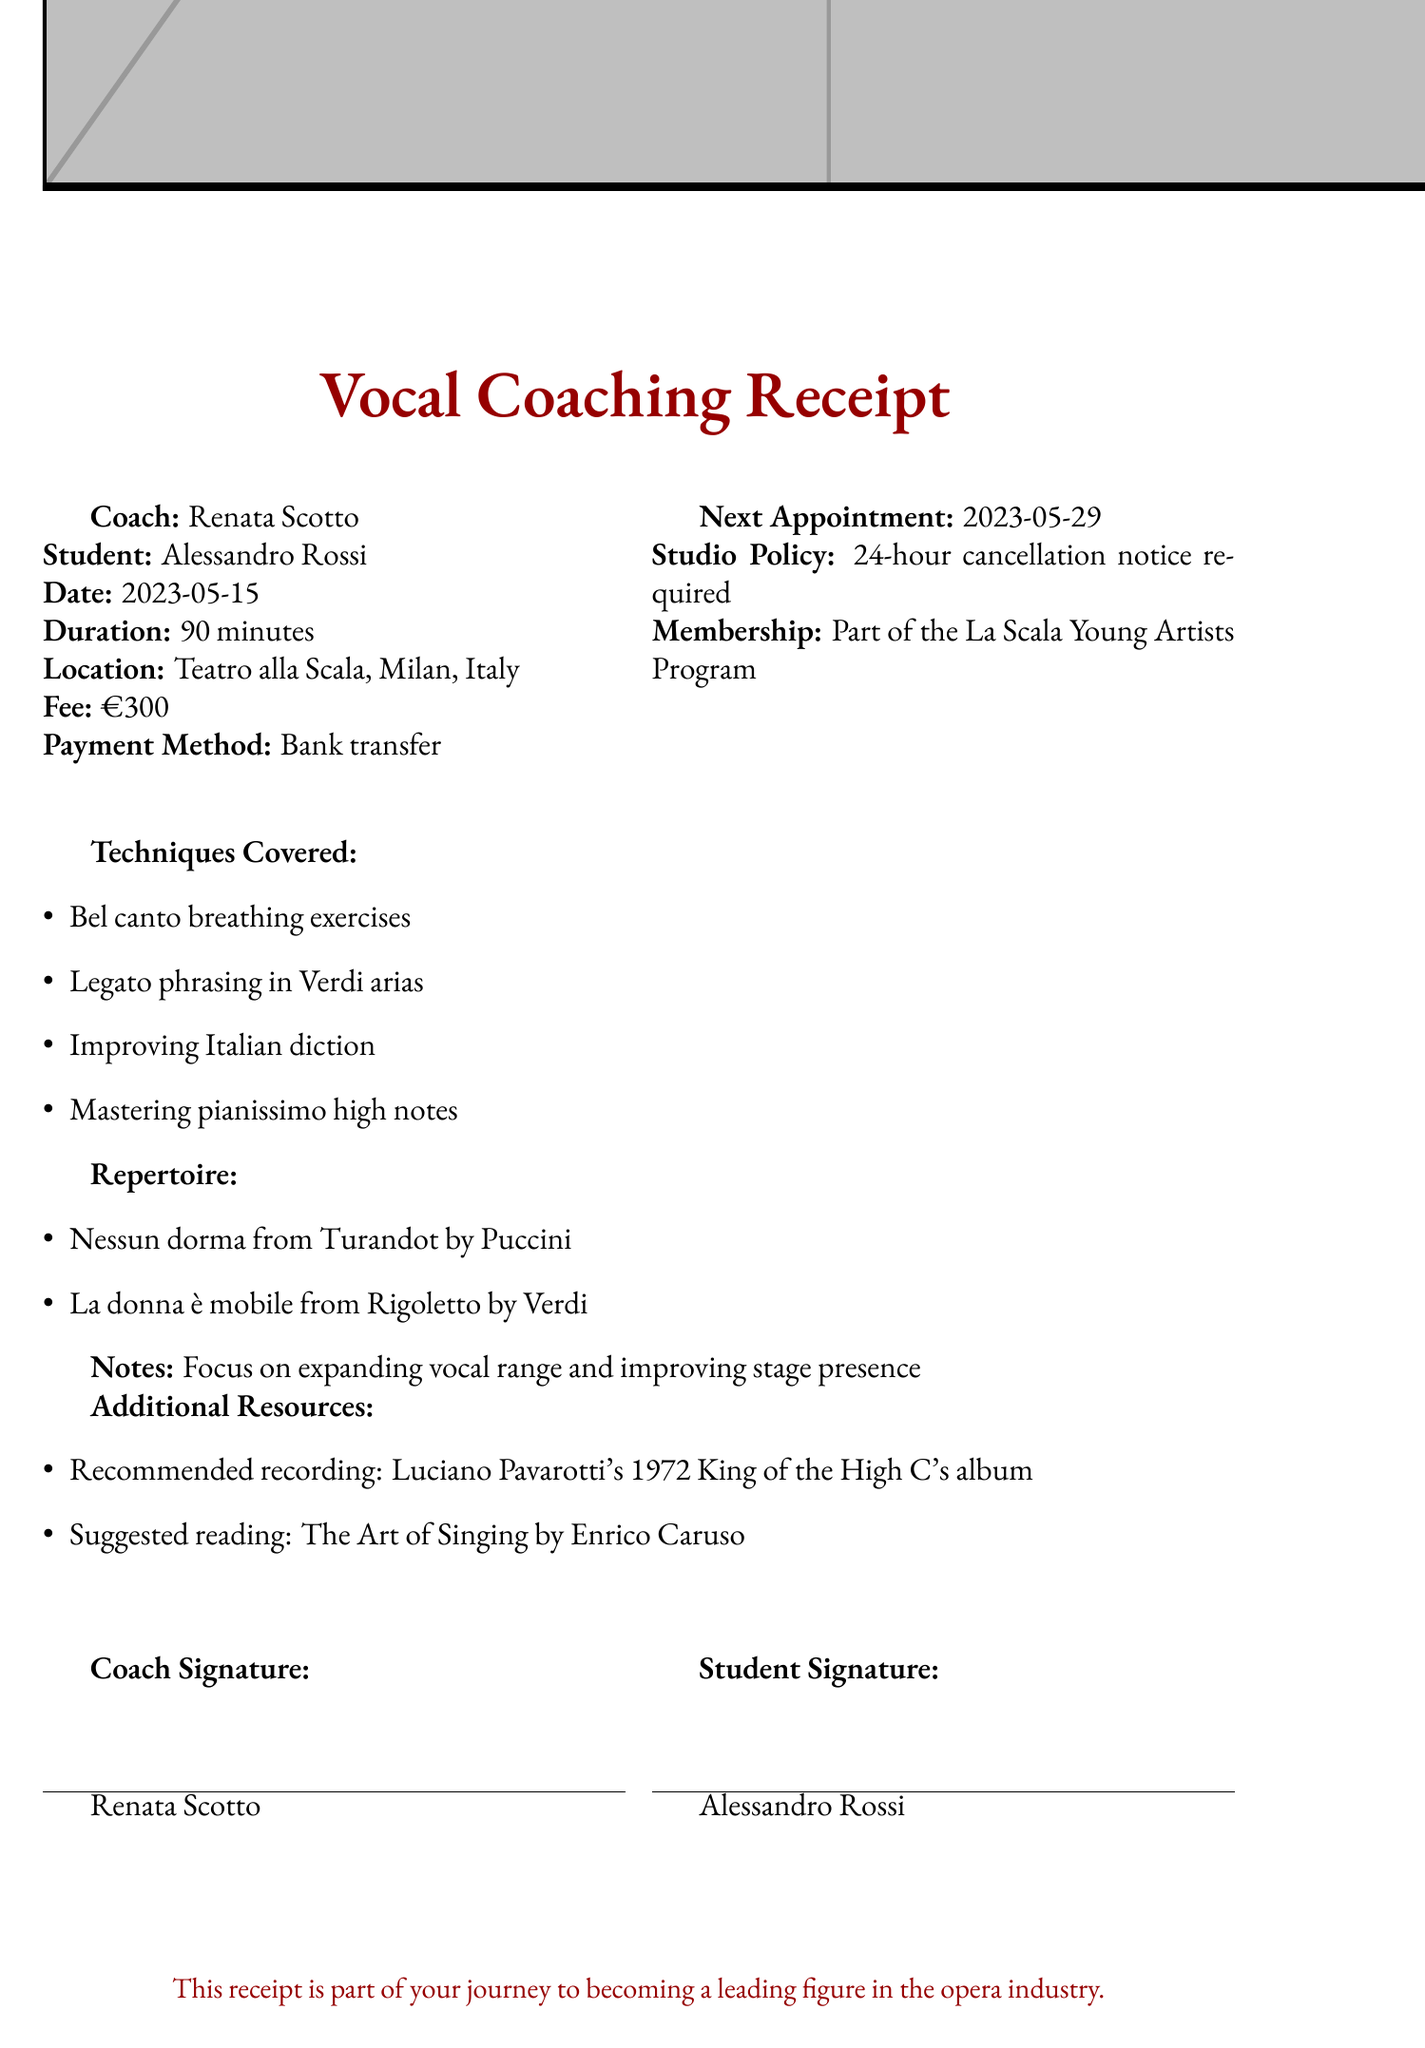What is the name of the coach? The document lists Renata Scotto as the name of the coach.
Answer: Renata Scotto Who is the student receiving the coaching? The document states that the student is Alessandro Rossi.
Answer: Alessandro Rossi What is the date of the coaching session? The document specifies that the date of the session is May 15, 2023.
Answer: 2023-05-15 How long was the coaching session? The session lasted for 90 minutes, as mentioned in the document.
Answer: 90 minutes What is the fee for the coaching session? The document indicates that the fee charged is €300.
Answer: €300 What techniques were covered during the session? The document lists several techniques, including bel canto breathing exercises, among others.
Answer: Bel canto breathing exercises What is the next appointment date? The next appointment is scheduled for May 29, 2023, according to the document.
Answer: 2023-05-29 What policy must be followed for cancellations? The document states that a 24-hour cancellation notice is required.
Answer: 24-hour cancellation notice required Which famous recording is recommended as an additional resource? The document suggests Luciano Pavarotti's 1972 King of the High C's album as a recommended recording.
Answer: Luciano Pavarotti's 1972 King of the High C's album 